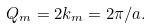<formula> <loc_0><loc_0><loc_500><loc_500>Q _ { m } = 2 k _ { m } = 2 \pi / a .</formula> 